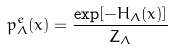Convert formula to latex. <formula><loc_0><loc_0><loc_500><loc_500>p _ { \Lambda } ^ { e } ( x ) = \frac { \exp [ - H _ { \Lambda } ( x ) ] } { Z _ { \Lambda } }</formula> 